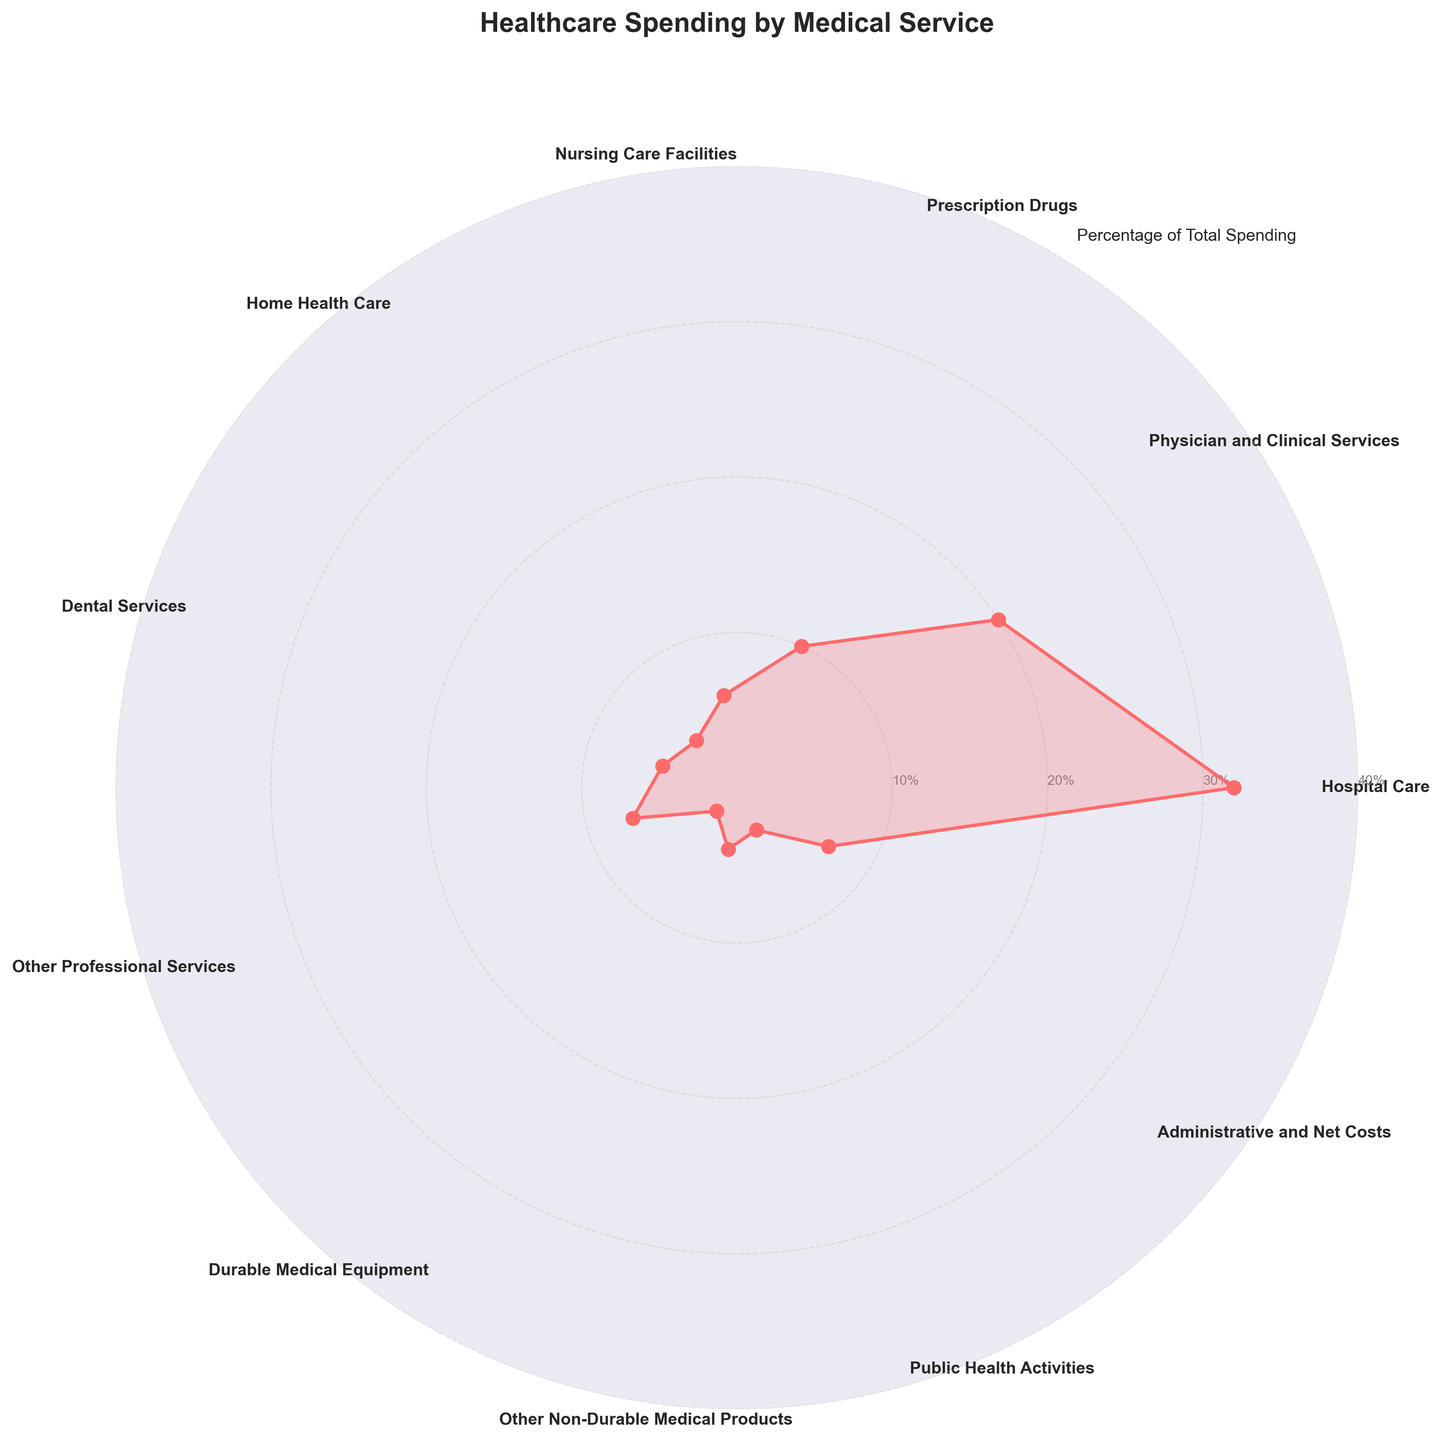What is the title of the polar chart? The title is usually positioned at the top of the chart. In this case, it reads "Healthcare Spending by Medical Service".
Answer: Healthcare Spending by Medical Service Which medical service has the highest spending percentage? Inspect the extensions of the plot points along the radial axis. The longest line represents the highest value. "Hospital Care" is the farthest from the center at 32%.
Answer: Hospital Care What is the combined spending percentage for Nursing Care Facilities and Home Health Care? Locate the values for Nursing Care Facilities (6%) and Home Health Care (4%), then add them together: 6% + 4% = 10%.
Answer: 10% Which medical service type has the least spending percentage? Identify the point on the plot that extends the least from the center. "Durable Medical Equipment" is the closest at 2%.
Answer: Durable Medical Equipment How does the spending percentage for Prescription Drugs compare to that of Nursing Care Facilities? Locate both values: Prescription Drugs (10%) and Nursing Care Facilities (6%), and compare them. Prescription Drugs has a higher percentage.
Answer: Prescription Drugs has a higher percentage What is the total spending percentage for Other Professional Services, Dental Services, and Public Health Activities combined? Locate the values of each: Other Professional Services (7%), Dental Services (5%), and Public Health Activities (3%). Sum them: 7% + 5% + 3% = 15%.
Answer: 15% What is the difference in spending percentage between Administrative and Net Costs and Durable Medical Equipment? Locate the values: Administrative and Net Costs (7%) and Durable Medical Equipment (2%). Subtract the smaller from the larger: 7% - 2% = 5%.
Answer: 5% What is the sum of all spending percentages depicted in the polar chart? Add all the individual percentages together: 32% + 20% + 10% + 6% + 4% + 5% + 7% + 2% + 4% + 3% + 7% = 100%.
Answer: 100% What percentage categories make up less than 5% of the total spending? Identify categories with values less than 5%: Home Health Care (4%), Durable Medical Equipment (2%), and Other Non-Durable Medical Products (4%), and Public Health Activities (3%).
Answer: Home Health Care, Durable Medical Equipment, Other Non-Durable Medical Products, Public Health Activities How many medical service categories are displayed in the chart? Count the number of distinct categories around the circle: Hospital Care, Physician and Clinical Services, Prescription Drugs, Nursing Care Facilities, Home Health Care, Dental Services, Other Professional Services, Durable Medical Equipment, Other Non-Durable Medical Products, Public Health Activities, Administrative and Net Costs. There are 11 categories.
Answer: 11 